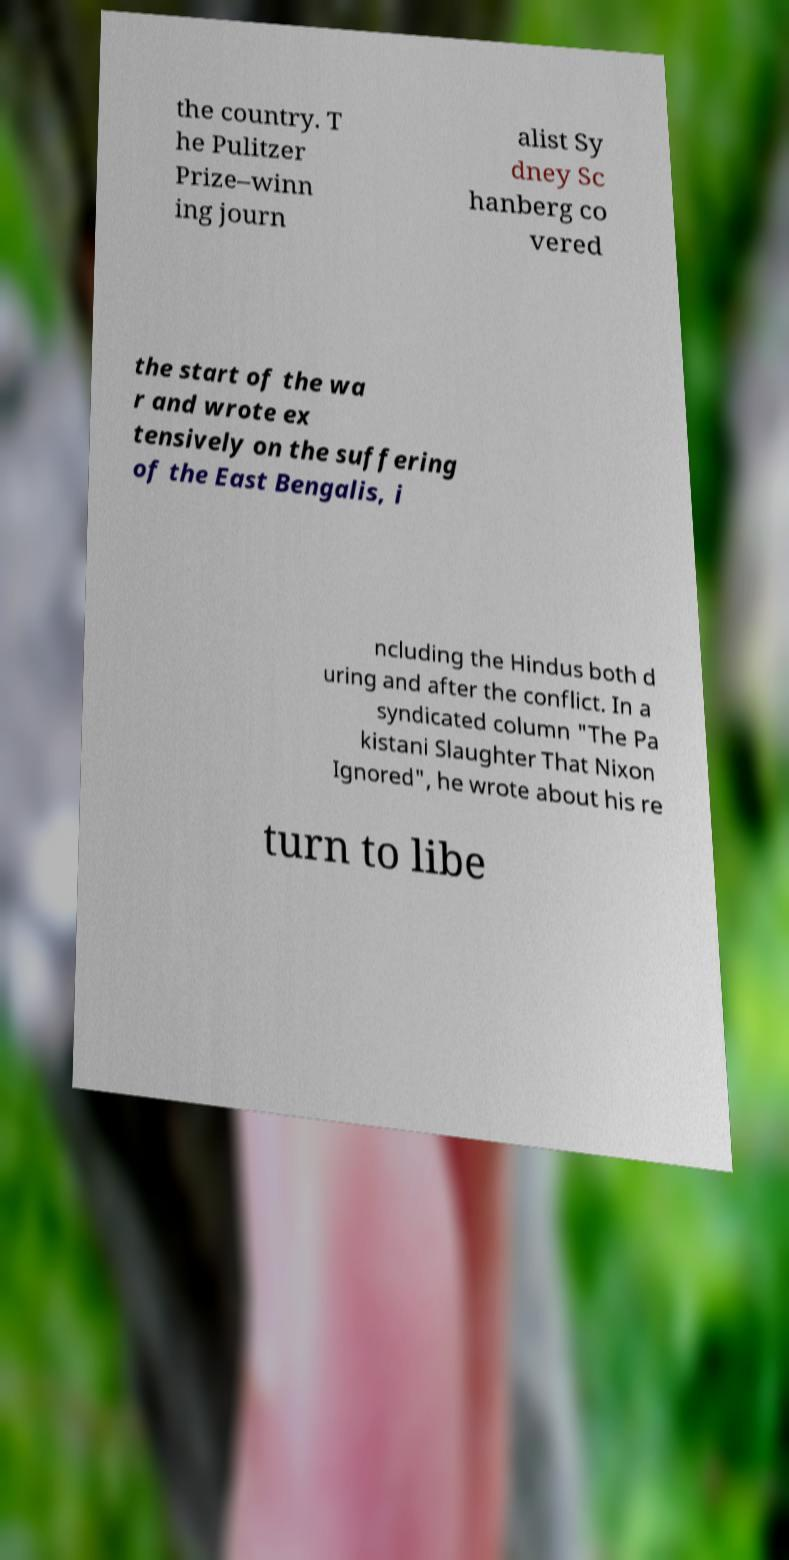Can you read and provide the text displayed in the image?This photo seems to have some interesting text. Can you extract and type it out for me? the country. T he Pulitzer Prize–winn ing journ alist Sy dney Sc hanberg co vered the start of the wa r and wrote ex tensively on the suffering of the East Bengalis, i ncluding the Hindus both d uring and after the conflict. In a syndicated column "The Pa kistani Slaughter That Nixon Ignored", he wrote about his re turn to libe 